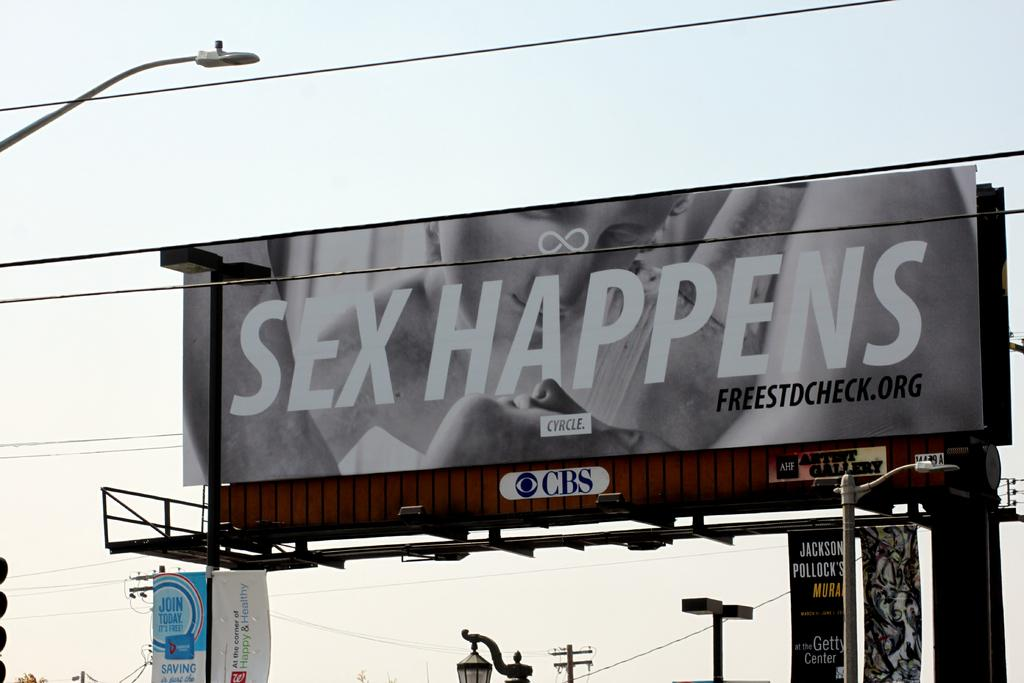<image>
Provide a brief description of the given image. A billboard of a women looking down at a man with the caption "Sex Happens". 